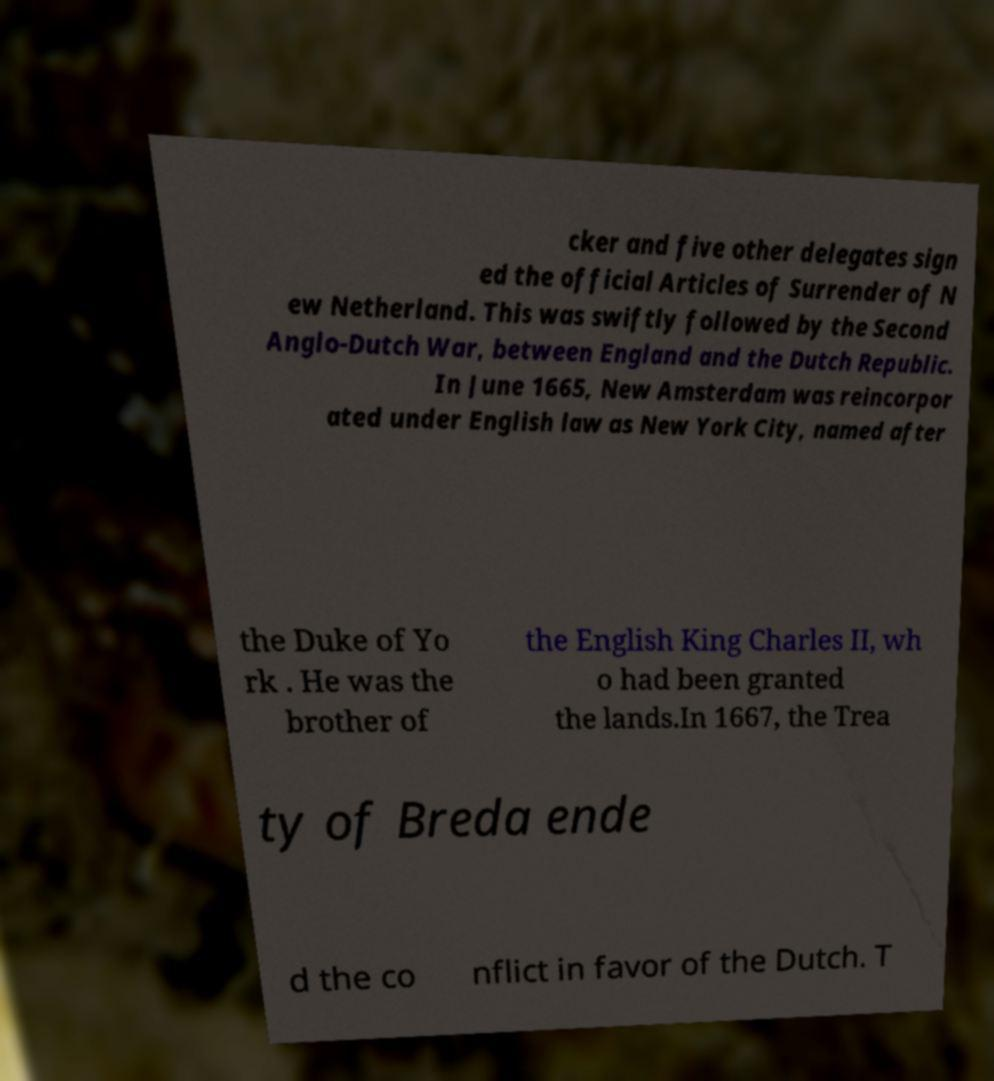Could you extract and type out the text from this image? cker and five other delegates sign ed the official Articles of Surrender of N ew Netherland. This was swiftly followed by the Second Anglo-Dutch War, between England and the Dutch Republic. In June 1665, New Amsterdam was reincorpor ated under English law as New York City, named after the Duke of Yo rk . He was the brother of the English King Charles II, wh o had been granted the lands.In 1667, the Trea ty of Breda ende d the co nflict in favor of the Dutch. T 